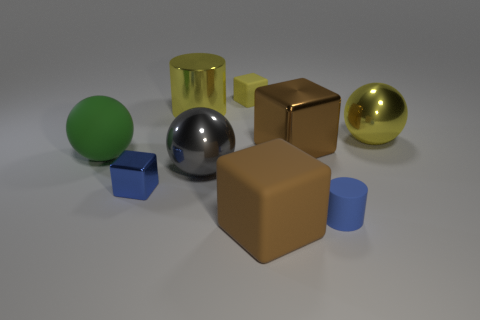Add 1 tiny blue rubber cylinders. How many objects exist? 10 Subtract all cylinders. How many objects are left? 7 Add 2 big green metallic cylinders. How many big green metallic cylinders exist? 2 Subtract 0 green blocks. How many objects are left? 9 Subtract all tiny yellow matte objects. Subtract all shiny cylinders. How many objects are left? 7 Add 9 big yellow metallic spheres. How many big yellow metallic spheres are left? 10 